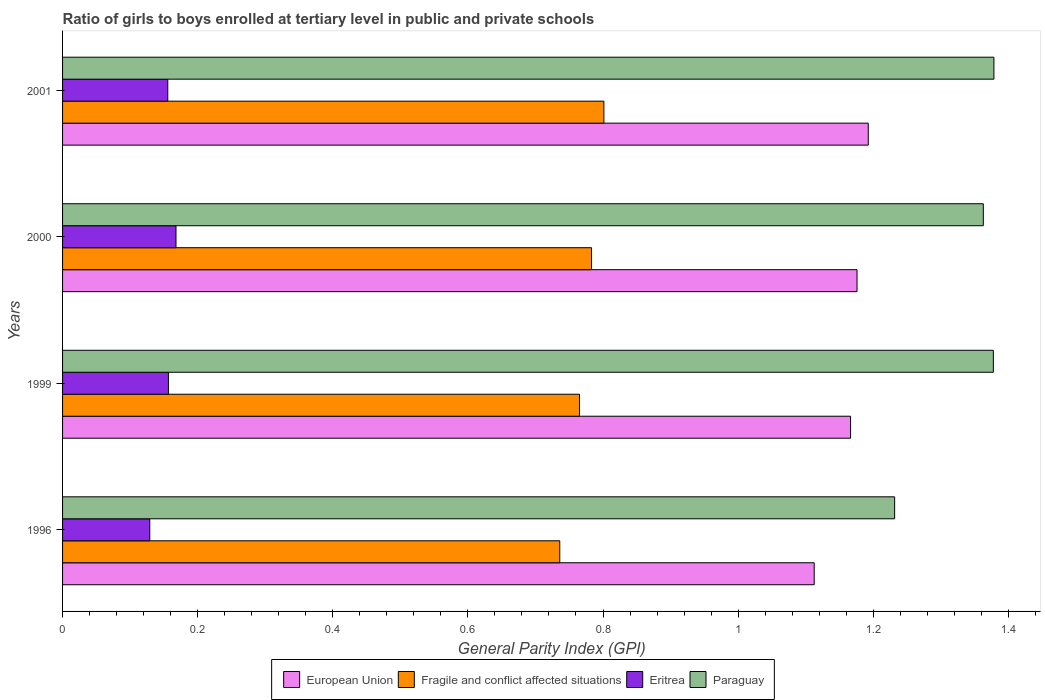How many different coloured bars are there?
Offer a terse response. 4. How many groups of bars are there?
Offer a very short reply. 4. Are the number of bars on each tick of the Y-axis equal?
Keep it short and to the point. Yes. How many bars are there on the 1st tick from the bottom?
Your answer should be very brief. 4. What is the label of the 3rd group of bars from the top?
Provide a succinct answer. 1999. What is the general parity index in Fragile and conflict affected situations in 1999?
Make the answer very short. 0.77. Across all years, what is the maximum general parity index in Fragile and conflict affected situations?
Keep it short and to the point. 0.8. Across all years, what is the minimum general parity index in Eritrea?
Make the answer very short. 0.13. What is the total general parity index in Eritrea in the graph?
Offer a terse response. 0.61. What is the difference between the general parity index in Paraguay in 1999 and that in 2001?
Ensure brevity in your answer.  -0. What is the difference between the general parity index in Paraguay in 2000 and the general parity index in Eritrea in 2001?
Keep it short and to the point. 1.21. What is the average general parity index in Fragile and conflict affected situations per year?
Your answer should be very brief. 0.77. In the year 2000, what is the difference between the general parity index in European Union and general parity index in Fragile and conflict affected situations?
Provide a short and direct response. 0.39. What is the ratio of the general parity index in European Union in 1996 to that in 1999?
Provide a short and direct response. 0.95. Is the difference between the general parity index in European Union in 1999 and 2001 greater than the difference between the general parity index in Fragile and conflict affected situations in 1999 and 2001?
Ensure brevity in your answer.  Yes. What is the difference between the highest and the second highest general parity index in Paraguay?
Give a very brief answer. 0. What is the difference between the highest and the lowest general parity index in Fragile and conflict affected situations?
Ensure brevity in your answer.  0.07. Is it the case that in every year, the sum of the general parity index in European Union and general parity index in Paraguay is greater than the sum of general parity index in Fragile and conflict affected situations and general parity index in Eritrea?
Provide a succinct answer. Yes. What does the 2nd bar from the top in 2001 represents?
Offer a terse response. Eritrea. What does the 4th bar from the bottom in 2000 represents?
Provide a short and direct response. Paraguay. How many bars are there?
Ensure brevity in your answer.  16. Are the values on the major ticks of X-axis written in scientific E-notation?
Offer a terse response. No. Does the graph contain any zero values?
Provide a short and direct response. No. Does the graph contain grids?
Offer a terse response. No. Where does the legend appear in the graph?
Offer a very short reply. Bottom center. How are the legend labels stacked?
Keep it short and to the point. Horizontal. What is the title of the graph?
Your answer should be very brief. Ratio of girls to boys enrolled at tertiary level in public and private schools. What is the label or title of the X-axis?
Offer a terse response. General Parity Index (GPI). What is the General Parity Index (GPI) of European Union in 1996?
Make the answer very short. 1.11. What is the General Parity Index (GPI) in Fragile and conflict affected situations in 1996?
Your answer should be very brief. 0.74. What is the General Parity Index (GPI) in Eritrea in 1996?
Give a very brief answer. 0.13. What is the General Parity Index (GPI) of Paraguay in 1996?
Keep it short and to the point. 1.23. What is the General Parity Index (GPI) in European Union in 1999?
Make the answer very short. 1.17. What is the General Parity Index (GPI) of Fragile and conflict affected situations in 1999?
Make the answer very short. 0.77. What is the General Parity Index (GPI) in Eritrea in 1999?
Your answer should be compact. 0.16. What is the General Parity Index (GPI) in Paraguay in 1999?
Provide a succinct answer. 1.38. What is the General Parity Index (GPI) in European Union in 2000?
Give a very brief answer. 1.18. What is the General Parity Index (GPI) in Fragile and conflict affected situations in 2000?
Your answer should be very brief. 0.78. What is the General Parity Index (GPI) of Eritrea in 2000?
Offer a terse response. 0.17. What is the General Parity Index (GPI) in Paraguay in 2000?
Ensure brevity in your answer.  1.36. What is the General Parity Index (GPI) of European Union in 2001?
Your answer should be very brief. 1.19. What is the General Parity Index (GPI) in Fragile and conflict affected situations in 2001?
Your answer should be compact. 0.8. What is the General Parity Index (GPI) of Eritrea in 2001?
Keep it short and to the point. 0.16. What is the General Parity Index (GPI) of Paraguay in 2001?
Provide a short and direct response. 1.38. Across all years, what is the maximum General Parity Index (GPI) of European Union?
Offer a very short reply. 1.19. Across all years, what is the maximum General Parity Index (GPI) in Fragile and conflict affected situations?
Your answer should be compact. 0.8. Across all years, what is the maximum General Parity Index (GPI) of Eritrea?
Your response must be concise. 0.17. Across all years, what is the maximum General Parity Index (GPI) in Paraguay?
Your response must be concise. 1.38. Across all years, what is the minimum General Parity Index (GPI) of European Union?
Make the answer very short. 1.11. Across all years, what is the minimum General Parity Index (GPI) of Fragile and conflict affected situations?
Provide a succinct answer. 0.74. Across all years, what is the minimum General Parity Index (GPI) of Eritrea?
Your answer should be compact. 0.13. Across all years, what is the minimum General Parity Index (GPI) of Paraguay?
Your response must be concise. 1.23. What is the total General Parity Index (GPI) of European Union in the graph?
Your response must be concise. 4.65. What is the total General Parity Index (GPI) of Fragile and conflict affected situations in the graph?
Offer a terse response. 3.09. What is the total General Parity Index (GPI) in Eritrea in the graph?
Your response must be concise. 0.61. What is the total General Parity Index (GPI) of Paraguay in the graph?
Your response must be concise. 5.35. What is the difference between the General Parity Index (GPI) in European Union in 1996 and that in 1999?
Ensure brevity in your answer.  -0.05. What is the difference between the General Parity Index (GPI) of Fragile and conflict affected situations in 1996 and that in 1999?
Your response must be concise. -0.03. What is the difference between the General Parity Index (GPI) of Eritrea in 1996 and that in 1999?
Give a very brief answer. -0.03. What is the difference between the General Parity Index (GPI) in Paraguay in 1996 and that in 1999?
Provide a short and direct response. -0.15. What is the difference between the General Parity Index (GPI) in European Union in 1996 and that in 2000?
Make the answer very short. -0.06. What is the difference between the General Parity Index (GPI) in Fragile and conflict affected situations in 1996 and that in 2000?
Ensure brevity in your answer.  -0.05. What is the difference between the General Parity Index (GPI) of Eritrea in 1996 and that in 2000?
Your answer should be compact. -0.04. What is the difference between the General Parity Index (GPI) of Paraguay in 1996 and that in 2000?
Give a very brief answer. -0.13. What is the difference between the General Parity Index (GPI) of European Union in 1996 and that in 2001?
Your answer should be compact. -0.08. What is the difference between the General Parity Index (GPI) of Fragile and conflict affected situations in 1996 and that in 2001?
Keep it short and to the point. -0.07. What is the difference between the General Parity Index (GPI) in Eritrea in 1996 and that in 2001?
Offer a very short reply. -0.03. What is the difference between the General Parity Index (GPI) in Paraguay in 1996 and that in 2001?
Ensure brevity in your answer.  -0.15. What is the difference between the General Parity Index (GPI) in European Union in 1999 and that in 2000?
Ensure brevity in your answer.  -0.01. What is the difference between the General Parity Index (GPI) in Fragile and conflict affected situations in 1999 and that in 2000?
Your answer should be compact. -0.02. What is the difference between the General Parity Index (GPI) of Eritrea in 1999 and that in 2000?
Your answer should be very brief. -0.01. What is the difference between the General Parity Index (GPI) of Paraguay in 1999 and that in 2000?
Make the answer very short. 0.01. What is the difference between the General Parity Index (GPI) of European Union in 1999 and that in 2001?
Provide a short and direct response. -0.03. What is the difference between the General Parity Index (GPI) of Fragile and conflict affected situations in 1999 and that in 2001?
Provide a short and direct response. -0.04. What is the difference between the General Parity Index (GPI) in Eritrea in 1999 and that in 2001?
Provide a short and direct response. 0. What is the difference between the General Parity Index (GPI) of Paraguay in 1999 and that in 2001?
Ensure brevity in your answer.  -0. What is the difference between the General Parity Index (GPI) in European Union in 2000 and that in 2001?
Ensure brevity in your answer.  -0.02. What is the difference between the General Parity Index (GPI) of Fragile and conflict affected situations in 2000 and that in 2001?
Your response must be concise. -0.02. What is the difference between the General Parity Index (GPI) of Eritrea in 2000 and that in 2001?
Provide a succinct answer. 0.01. What is the difference between the General Parity Index (GPI) of Paraguay in 2000 and that in 2001?
Provide a short and direct response. -0.02. What is the difference between the General Parity Index (GPI) of European Union in 1996 and the General Parity Index (GPI) of Fragile and conflict affected situations in 1999?
Provide a short and direct response. 0.35. What is the difference between the General Parity Index (GPI) in European Union in 1996 and the General Parity Index (GPI) in Eritrea in 1999?
Your answer should be compact. 0.96. What is the difference between the General Parity Index (GPI) of European Union in 1996 and the General Parity Index (GPI) of Paraguay in 1999?
Ensure brevity in your answer.  -0.27. What is the difference between the General Parity Index (GPI) of Fragile and conflict affected situations in 1996 and the General Parity Index (GPI) of Eritrea in 1999?
Your response must be concise. 0.58. What is the difference between the General Parity Index (GPI) of Fragile and conflict affected situations in 1996 and the General Parity Index (GPI) of Paraguay in 1999?
Provide a succinct answer. -0.64. What is the difference between the General Parity Index (GPI) in Eritrea in 1996 and the General Parity Index (GPI) in Paraguay in 1999?
Give a very brief answer. -1.25. What is the difference between the General Parity Index (GPI) in European Union in 1996 and the General Parity Index (GPI) in Fragile and conflict affected situations in 2000?
Provide a succinct answer. 0.33. What is the difference between the General Parity Index (GPI) in European Union in 1996 and the General Parity Index (GPI) in Eritrea in 2000?
Offer a very short reply. 0.94. What is the difference between the General Parity Index (GPI) of European Union in 1996 and the General Parity Index (GPI) of Paraguay in 2000?
Provide a short and direct response. -0.25. What is the difference between the General Parity Index (GPI) in Fragile and conflict affected situations in 1996 and the General Parity Index (GPI) in Eritrea in 2000?
Ensure brevity in your answer.  0.57. What is the difference between the General Parity Index (GPI) of Fragile and conflict affected situations in 1996 and the General Parity Index (GPI) of Paraguay in 2000?
Provide a short and direct response. -0.63. What is the difference between the General Parity Index (GPI) of Eritrea in 1996 and the General Parity Index (GPI) of Paraguay in 2000?
Give a very brief answer. -1.23. What is the difference between the General Parity Index (GPI) of European Union in 1996 and the General Parity Index (GPI) of Fragile and conflict affected situations in 2001?
Your answer should be compact. 0.31. What is the difference between the General Parity Index (GPI) in European Union in 1996 and the General Parity Index (GPI) in Eritrea in 2001?
Ensure brevity in your answer.  0.96. What is the difference between the General Parity Index (GPI) of European Union in 1996 and the General Parity Index (GPI) of Paraguay in 2001?
Keep it short and to the point. -0.27. What is the difference between the General Parity Index (GPI) of Fragile and conflict affected situations in 1996 and the General Parity Index (GPI) of Eritrea in 2001?
Give a very brief answer. 0.58. What is the difference between the General Parity Index (GPI) of Fragile and conflict affected situations in 1996 and the General Parity Index (GPI) of Paraguay in 2001?
Make the answer very short. -0.64. What is the difference between the General Parity Index (GPI) in Eritrea in 1996 and the General Parity Index (GPI) in Paraguay in 2001?
Your response must be concise. -1.25. What is the difference between the General Parity Index (GPI) in European Union in 1999 and the General Parity Index (GPI) in Fragile and conflict affected situations in 2000?
Ensure brevity in your answer.  0.38. What is the difference between the General Parity Index (GPI) in European Union in 1999 and the General Parity Index (GPI) in Paraguay in 2000?
Ensure brevity in your answer.  -0.2. What is the difference between the General Parity Index (GPI) of Fragile and conflict affected situations in 1999 and the General Parity Index (GPI) of Eritrea in 2000?
Make the answer very short. 0.6. What is the difference between the General Parity Index (GPI) in Fragile and conflict affected situations in 1999 and the General Parity Index (GPI) in Paraguay in 2000?
Keep it short and to the point. -0.6. What is the difference between the General Parity Index (GPI) of Eritrea in 1999 and the General Parity Index (GPI) of Paraguay in 2000?
Your answer should be compact. -1.21. What is the difference between the General Parity Index (GPI) in European Union in 1999 and the General Parity Index (GPI) in Fragile and conflict affected situations in 2001?
Keep it short and to the point. 0.37. What is the difference between the General Parity Index (GPI) of European Union in 1999 and the General Parity Index (GPI) of Eritrea in 2001?
Make the answer very short. 1.01. What is the difference between the General Parity Index (GPI) of European Union in 1999 and the General Parity Index (GPI) of Paraguay in 2001?
Your response must be concise. -0.21. What is the difference between the General Parity Index (GPI) of Fragile and conflict affected situations in 1999 and the General Parity Index (GPI) of Eritrea in 2001?
Your answer should be very brief. 0.61. What is the difference between the General Parity Index (GPI) of Fragile and conflict affected situations in 1999 and the General Parity Index (GPI) of Paraguay in 2001?
Your answer should be very brief. -0.61. What is the difference between the General Parity Index (GPI) of Eritrea in 1999 and the General Parity Index (GPI) of Paraguay in 2001?
Offer a very short reply. -1.22. What is the difference between the General Parity Index (GPI) of European Union in 2000 and the General Parity Index (GPI) of Fragile and conflict affected situations in 2001?
Ensure brevity in your answer.  0.37. What is the difference between the General Parity Index (GPI) in European Union in 2000 and the General Parity Index (GPI) in Eritrea in 2001?
Make the answer very short. 1.02. What is the difference between the General Parity Index (GPI) of European Union in 2000 and the General Parity Index (GPI) of Paraguay in 2001?
Provide a short and direct response. -0.2. What is the difference between the General Parity Index (GPI) in Fragile and conflict affected situations in 2000 and the General Parity Index (GPI) in Eritrea in 2001?
Your response must be concise. 0.63. What is the difference between the General Parity Index (GPI) of Fragile and conflict affected situations in 2000 and the General Parity Index (GPI) of Paraguay in 2001?
Your answer should be very brief. -0.6. What is the difference between the General Parity Index (GPI) in Eritrea in 2000 and the General Parity Index (GPI) in Paraguay in 2001?
Your answer should be compact. -1.21. What is the average General Parity Index (GPI) in European Union per year?
Ensure brevity in your answer.  1.16. What is the average General Parity Index (GPI) of Fragile and conflict affected situations per year?
Your response must be concise. 0.77. What is the average General Parity Index (GPI) in Eritrea per year?
Your response must be concise. 0.15. What is the average General Parity Index (GPI) in Paraguay per year?
Provide a short and direct response. 1.34. In the year 1996, what is the difference between the General Parity Index (GPI) in European Union and General Parity Index (GPI) in Fragile and conflict affected situations?
Ensure brevity in your answer.  0.38. In the year 1996, what is the difference between the General Parity Index (GPI) in European Union and General Parity Index (GPI) in Eritrea?
Keep it short and to the point. 0.98. In the year 1996, what is the difference between the General Parity Index (GPI) of European Union and General Parity Index (GPI) of Paraguay?
Keep it short and to the point. -0.12. In the year 1996, what is the difference between the General Parity Index (GPI) in Fragile and conflict affected situations and General Parity Index (GPI) in Eritrea?
Provide a short and direct response. 0.61. In the year 1996, what is the difference between the General Parity Index (GPI) of Fragile and conflict affected situations and General Parity Index (GPI) of Paraguay?
Offer a terse response. -0.5. In the year 1996, what is the difference between the General Parity Index (GPI) in Eritrea and General Parity Index (GPI) in Paraguay?
Offer a very short reply. -1.1. In the year 1999, what is the difference between the General Parity Index (GPI) in European Union and General Parity Index (GPI) in Fragile and conflict affected situations?
Provide a short and direct response. 0.4. In the year 1999, what is the difference between the General Parity Index (GPI) of European Union and General Parity Index (GPI) of Eritrea?
Give a very brief answer. 1.01. In the year 1999, what is the difference between the General Parity Index (GPI) in European Union and General Parity Index (GPI) in Paraguay?
Your answer should be compact. -0.21. In the year 1999, what is the difference between the General Parity Index (GPI) of Fragile and conflict affected situations and General Parity Index (GPI) of Eritrea?
Ensure brevity in your answer.  0.61. In the year 1999, what is the difference between the General Parity Index (GPI) in Fragile and conflict affected situations and General Parity Index (GPI) in Paraguay?
Make the answer very short. -0.61. In the year 1999, what is the difference between the General Parity Index (GPI) in Eritrea and General Parity Index (GPI) in Paraguay?
Ensure brevity in your answer.  -1.22. In the year 2000, what is the difference between the General Parity Index (GPI) in European Union and General Parity Index (GPI) in Fragile and conflict affected situations?
Ensure brevity in your answer.  0.39. In the year 2000, what is the difference between the General Parity Index (GPI) in European Union and General Parity Index (GPI) in Eritrea?
Provide a succinct answer. 1.01. In the year 2000, what is the difference between the General Parity Index (GPI) of European Union and General Parity Index (GPI) of Paraguay?
Offer a terse response. -0.19. In the year 2000, what is the difference between the General Parity Index (GPI) of Fragile and conflict affected situations and General Parity Index (GPI) of Eritrea?
Your response must be concise. 0.62. In the year 2000, what is the difference between the General Parity Index (GPI) of Fragile and conflict affected situations and General Parity Index (GPI) of Paraguay?
Give a very brief answer. -0.58. In the year 2000, what is the difference between the General Parity Index (GPI) of Eritrea and General Parity Index (GPI) of Paraguay?
Provide a succinct answer. -1.2. In the year 2001, what is the difference between the General Parity Index (GPI) of European Union and General Parity Index (GPI) of Fragile and conflict affected situations?
Offer a very short reply. 0.39. In the year 2001, what is the difference between the General Parity Index (GPI) of European Union and General Parity Index (GPI) of Eritrea?
Your answer should be very brief. 1.04. In the year 2001, what is the difference between the General Parity Index (GPI) of European Union and General Parity Index (GPI) of Paraguay?
Provide a short and direct response. -0.19. In the year 2001, what is the difference between the General Parity Index (GPI) of Fragile and conflict affected situations and General Parity Index (GPI) of Eritrea?
Offer a very short reply. 0.65. In the year 2001, what is the difference between the General Parity Index (GPI) in Fragile and conflict affected situations and General Parity Index (GPI) in Paraguay?
Offer a terse response. -0.58. In the year 2001, what is the difference between the General Parity Index (GPI) of Eritrea and General Parity Index (GPI) of Paraguay?
Your answer should be very brief. -1.22. What is the ratio of the General Parity Index (GPI) in European Union in 1996 to that in 1999?
Offer a terse response. 0.95. What is the ratio of the General Parity Index (GPI) of Fragile and conflict affected situations in 1996 to that in 1999?
Your answer should be compact. 0.96. What is the ratio of the General Parity Index (GPI) in Eritrea in 1996 to that in 1999?
Offer a very short reply. 0.82. What is the ratio of the General Parity Index (GPI) of Paraguay in 1996 to that in 1999?
Make the answer very short. 0.89. What is the ratio of the General Parity Index (GPI) of European Union in 1996 to that in 2000?
Your answer should be compact. 0.95. What is the ratio of the General Parity Index (GPI) of Fragile and conflict affected situations in 1996 to that in 2000?
Provide a succinct answer. 0.94. What is the ratio of the General Parity Index (GPI) of Eritrea in 1996 to that in 2000?
Keep it short and to the point. 0.77. What is the ratio of the General Parity Index (GPI) of Paraguay in 1996 to that in 2000?
Keep it short and to the point. 0.9. What is the ratio of the General Parity Index (GPI) of European Union in 1996 to that in 2001?
Provide a succinct answer. 0.93. What is the ratio of the General Parity Index (GPI) in Fragile and conflict affected situations in 1996 to that in 2001?
Provide a succinct answer. 0.92. What is the ratio of the General Parity Index (GPI) of Eritrea in 1996 to that in 2001?
Ensure brevity in your answer.  0.83. What is the ratio of the General Parity Index (GPI) of Paraguay in 1996 to that in 2001?
Ensure brevity in your answer.  0.89. What is the ratio of the General Parity Index (GPI) in Fragile and conflict affected situations in 1999 to that in 2000?
Provide a succinct answer. 0.98. What is the ratio of the General Parity Index (GPI) of Eritrea in 1999 to that in 2000?
Ensure brevity in your answer.  0.93. What is the ratio of the General Parity Index (GPI) of Paraguay in 1999 to that in 2000?
Provide a short and direct response. 1.01. What is the ratio of the General Parity Index (GPI) of Fragile and conflict affected situations in 1999 to that in 2001?
Give a very brief answer. 0.95. What is the ratio of the General Parity Index (GPI) in Eritrea in 1999 to that in 2001?
Give a very brief answer. 1.01. What is the ratio of the General Parity Index (GPI) of Paraguay in 1999 to that in 2001?
Your answer should be compact. 1. What is the ratio of the General Parity Index (GPI) in European Union in 2000 to that in 2001?
Your answer should be compact. 0.99. What is the ratio of the General Parity Index (GPI) in Fragile and conflict affected situations in 2000 to that in 2001?
Your answer should be compact. 0.98. What is the ratio of the General Parity Index (GPI) of Eritrea in 2000 to that in 2001?
Keep it short and to the point. 1.08. What is the ratio of the General Parity Index (GPI) of Paraguay in 2000 to that in 2001?
Keep it short and to the point. 0.99. What is the difference between the highest and the second highest General Parity Index (GPI) in European Union?
Offer a terse response. 0.02. What is the difference between the highest and the second highest General Parity Index (GPI) in Fragile and conflict affected situations?
Offer a terse response. 0.02. What is the difference between the highest and the second highest General Parity Index (GPI) in Eritrea?
Your answer should be very brief. 0.01. What is the difference between the highest and the second highest General Parity Index (GPI) in Paraguay?
Keep it short and to the point. 0. What is the difference between the highest and the lowest General Parity Index (GPI) of European Union?
Give a very brief answer. 0.08. What is the difference between the highest and the lowest General Parity Index (GPI) in Fragile and conflict affected situations?
Offer a very short reply. 0.07. What is the difference between the highest and the lowest General Parity Index (GPI) in Eritrea?
Keep it short and to the point. 0.04. What is the difference between the highest and the lowest General Parity Index (GPI) in Paraguay?
Make the answer very short. 0.15. 